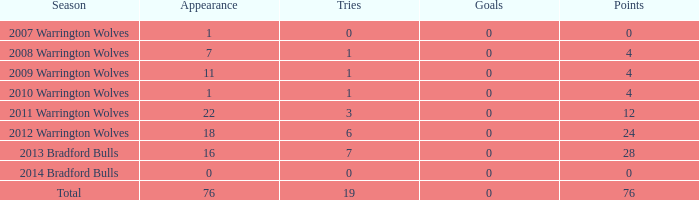For warrington wolves players with at least 8 appearances, what was the average tries scored during the 2008 season? None. 